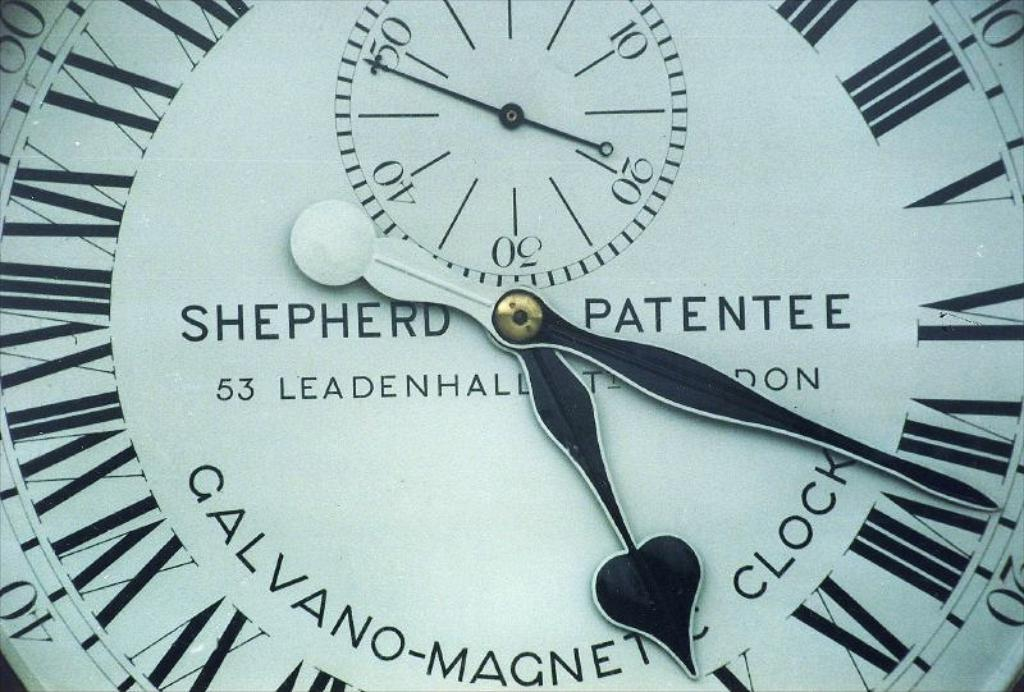<image>
Relay a brief, clear account of the picture shown. A clock made by shepherd is covered under a patent. 